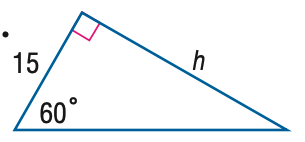Question: Find h.
Choices:
A. \frac { 15 \sqrt { 3 } } { 2 }
B. 15
C. 15 \sqrt 2
D. 15 \sqrt 3
Answer with the letter. Answer: D 